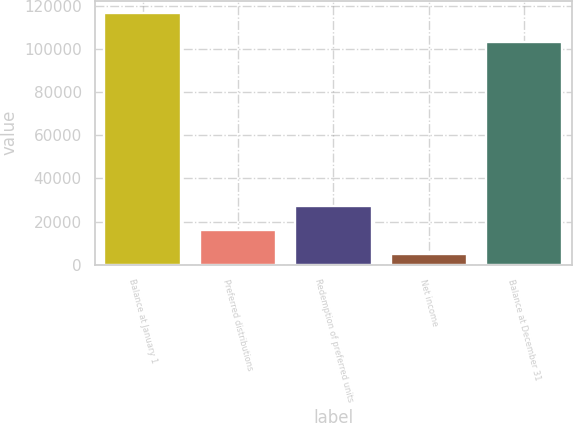Convert chart to OTSL. <chart><loc_0><loc_0><loc_500><loc_500><bar_chart><fcel>Balance at January 1<fcel>Preferred distributions<fcel>Redemption of preferred units<fcel>Net income<fcel>Balance at December 31<nl><fcel>116656<fcel>16133.2<fcel>27302.4<fcel>4964<fcel>103428<nl></chart> 